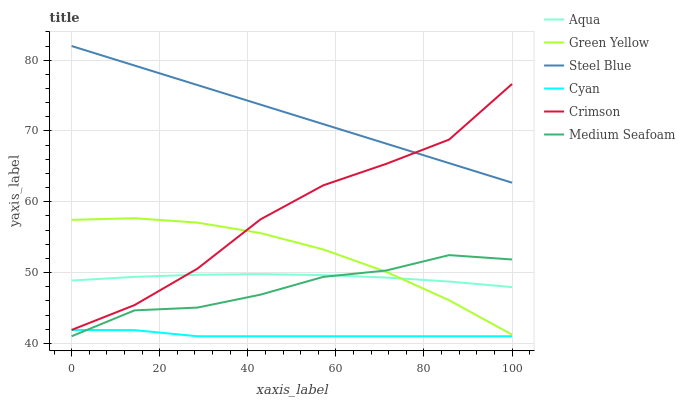Does Cyan have the minimum area under the curve?
Answer yes or no. Yes. Does Steel Blue have the maximum area under the curve?
Answer yes or no. Yes. Does Crimson have the minimum area under the curve?
Answer yes or no. No. Does Crimson have the maximum area under the curve?
Answer yes or no. No. Is Steel Blue the smoothest?
Answer yes or no. Yes. Is Crimson the roughest?
Answer yes or no. Yes. Is Crimson the smoothest?
Answer yes or no. No. Is Steel Blue the roughest?
Answer yes or no. No. Does Cyan have the lowest value?
Answer yes or no. Yes. Does Crimson have the lowest value?
Answer yes or no. No. Does Steel Blue have the highest value?
Answer yes or no. Yes. Does Crimson have the highest value?
Answer yes or no. No. Is Cyan less than Green Yellow?
Answer yes or no. Yes. Is Steel Blue greater than Green Yellow?
Answer yes or no. Yes. Does Steel Blue intersect Crimson?
Answer yes or no. Yes. Is Steel Blue less than Crimson?
Answer yes or no. No. Is Steel Blue greater than Crimson?
Answer yes or no. No. Does Cyan intersect Green Yellow?
Answer yes or no. No. 